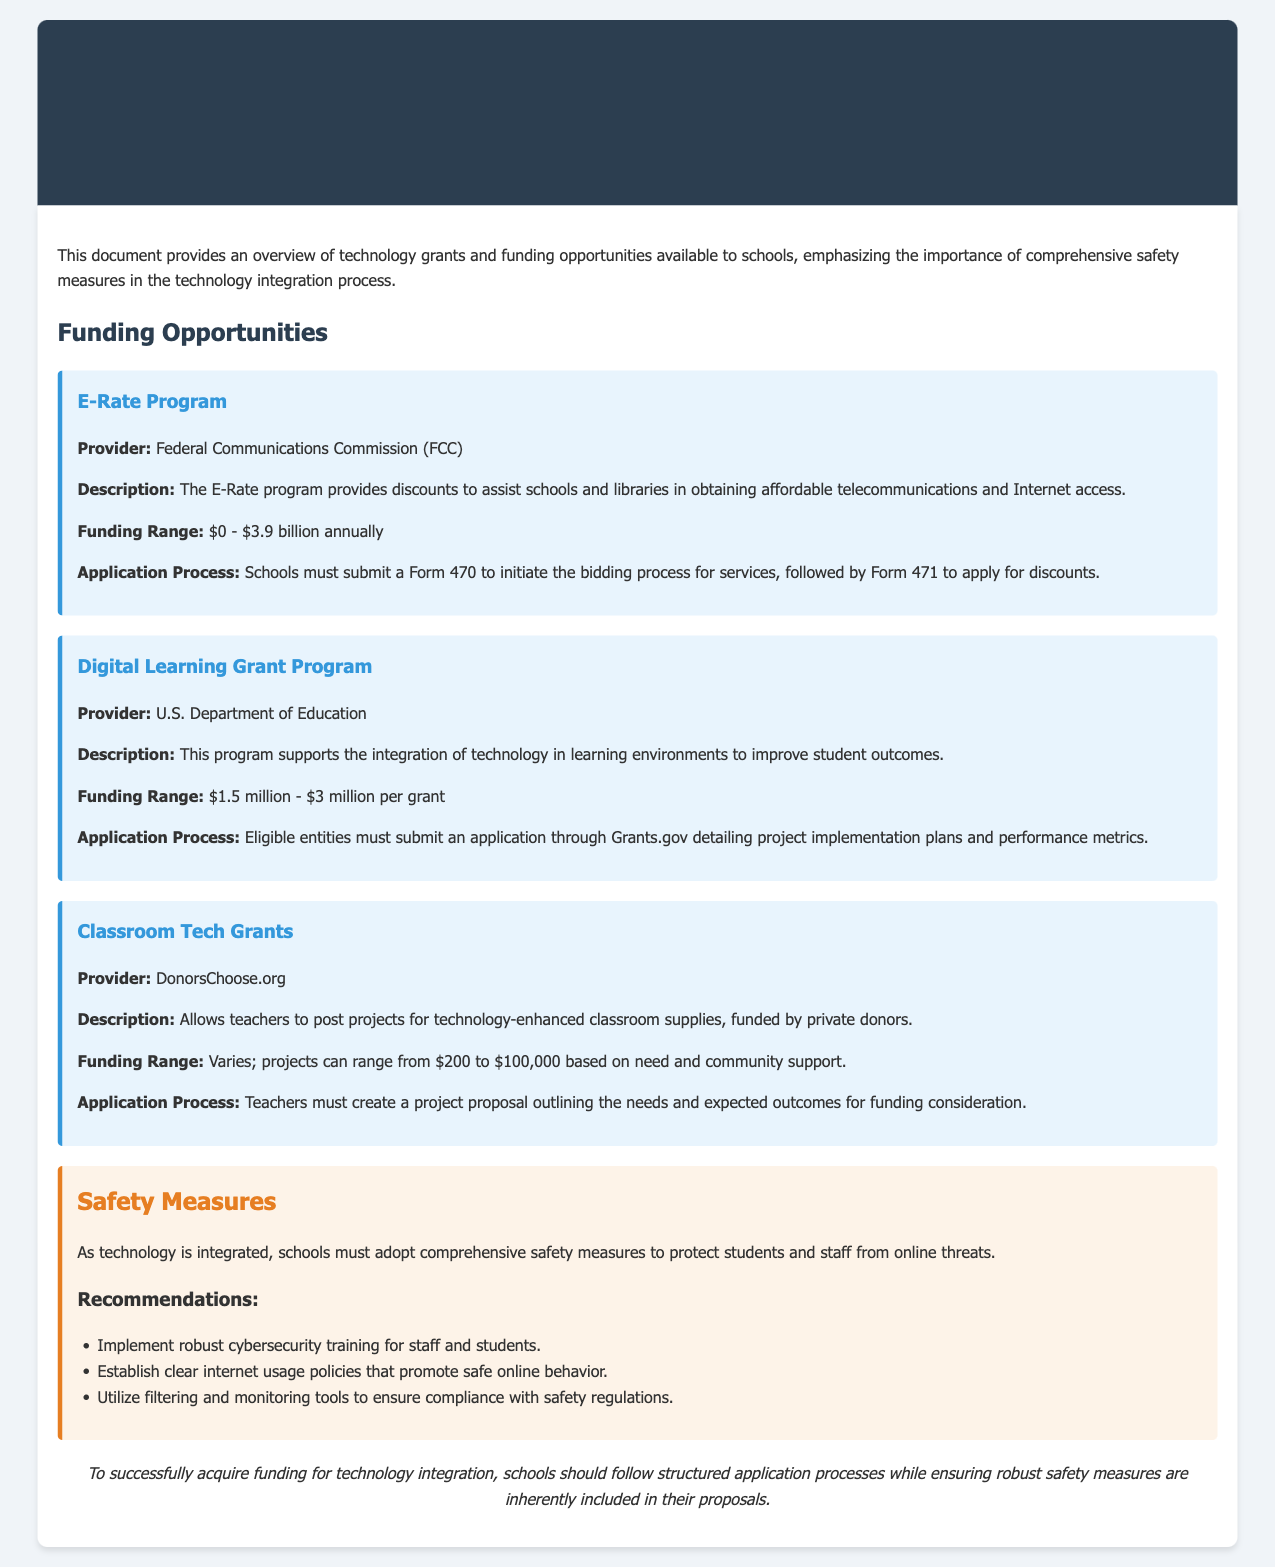What is the name of the program that provides discounts for telecommunications in schools? The E-Rate Program provides discounts to assist schools in obtaining affordable telecommunications and Internet access.
Answer: E-Rate Program Who is the provider of the Digital Learning Grant Program? The provider of the Digital Learning Grant Program is the U.S. Department of Education.
Answer: U.S. Department of Education What is the funding range for Classroom Tech Grants? The funding range for Classroom Tech Grants varies, with projects ranging from $200 to $100,000.
Answer: $200 to $100,000 What form must schools submit to initiate the E-Rate application process? Schools need to submit Form 470 to initiate the bidding process for E-Rate services.
Answer: Form 470 What is one recommendation for safety measures in technology integration? One recommendation is to implement robust cybersecurity training for staff and students.
Answer: Cybersecurity training How much funding is available through the Digital Learning Grant Program? The Digital Learning Grant Program provides between $1.5 million and $3 million per grant.
Answer: $1.5 million - $3 million What is the main focus of the document? The document provides an overview of technology grants and funding opportunities available to schools, emphasizing the importance of safety measures.
Answer: Overview of technology grants Which website allows teachers to post technology project proposals? DonorsChoose.org allows teachers to post projects for technology-enhanced classroom supplies.
Answer: DonorsChoose.org 